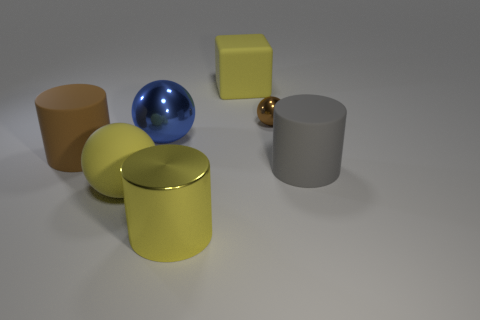Add 2 large metal balls. How many objects exist? 9 Subtract all large balls. How many balls are left? 1 Subtract all blocks. How many objects are left? 6 Subtract all purple balls. Subtract all purple cylinders. How many balls are left? 3 Add 2 tiny brown metal things. How many tiny brown metal things are left? 3 Add 3 cyan matte objects. How many cyan matte objects exist? 3 Subtract 0 purple cylinders. How many objects are left? 7 Subtract all big blue shiny things. Subtract all big matte blocks. How many objects are left? 5 